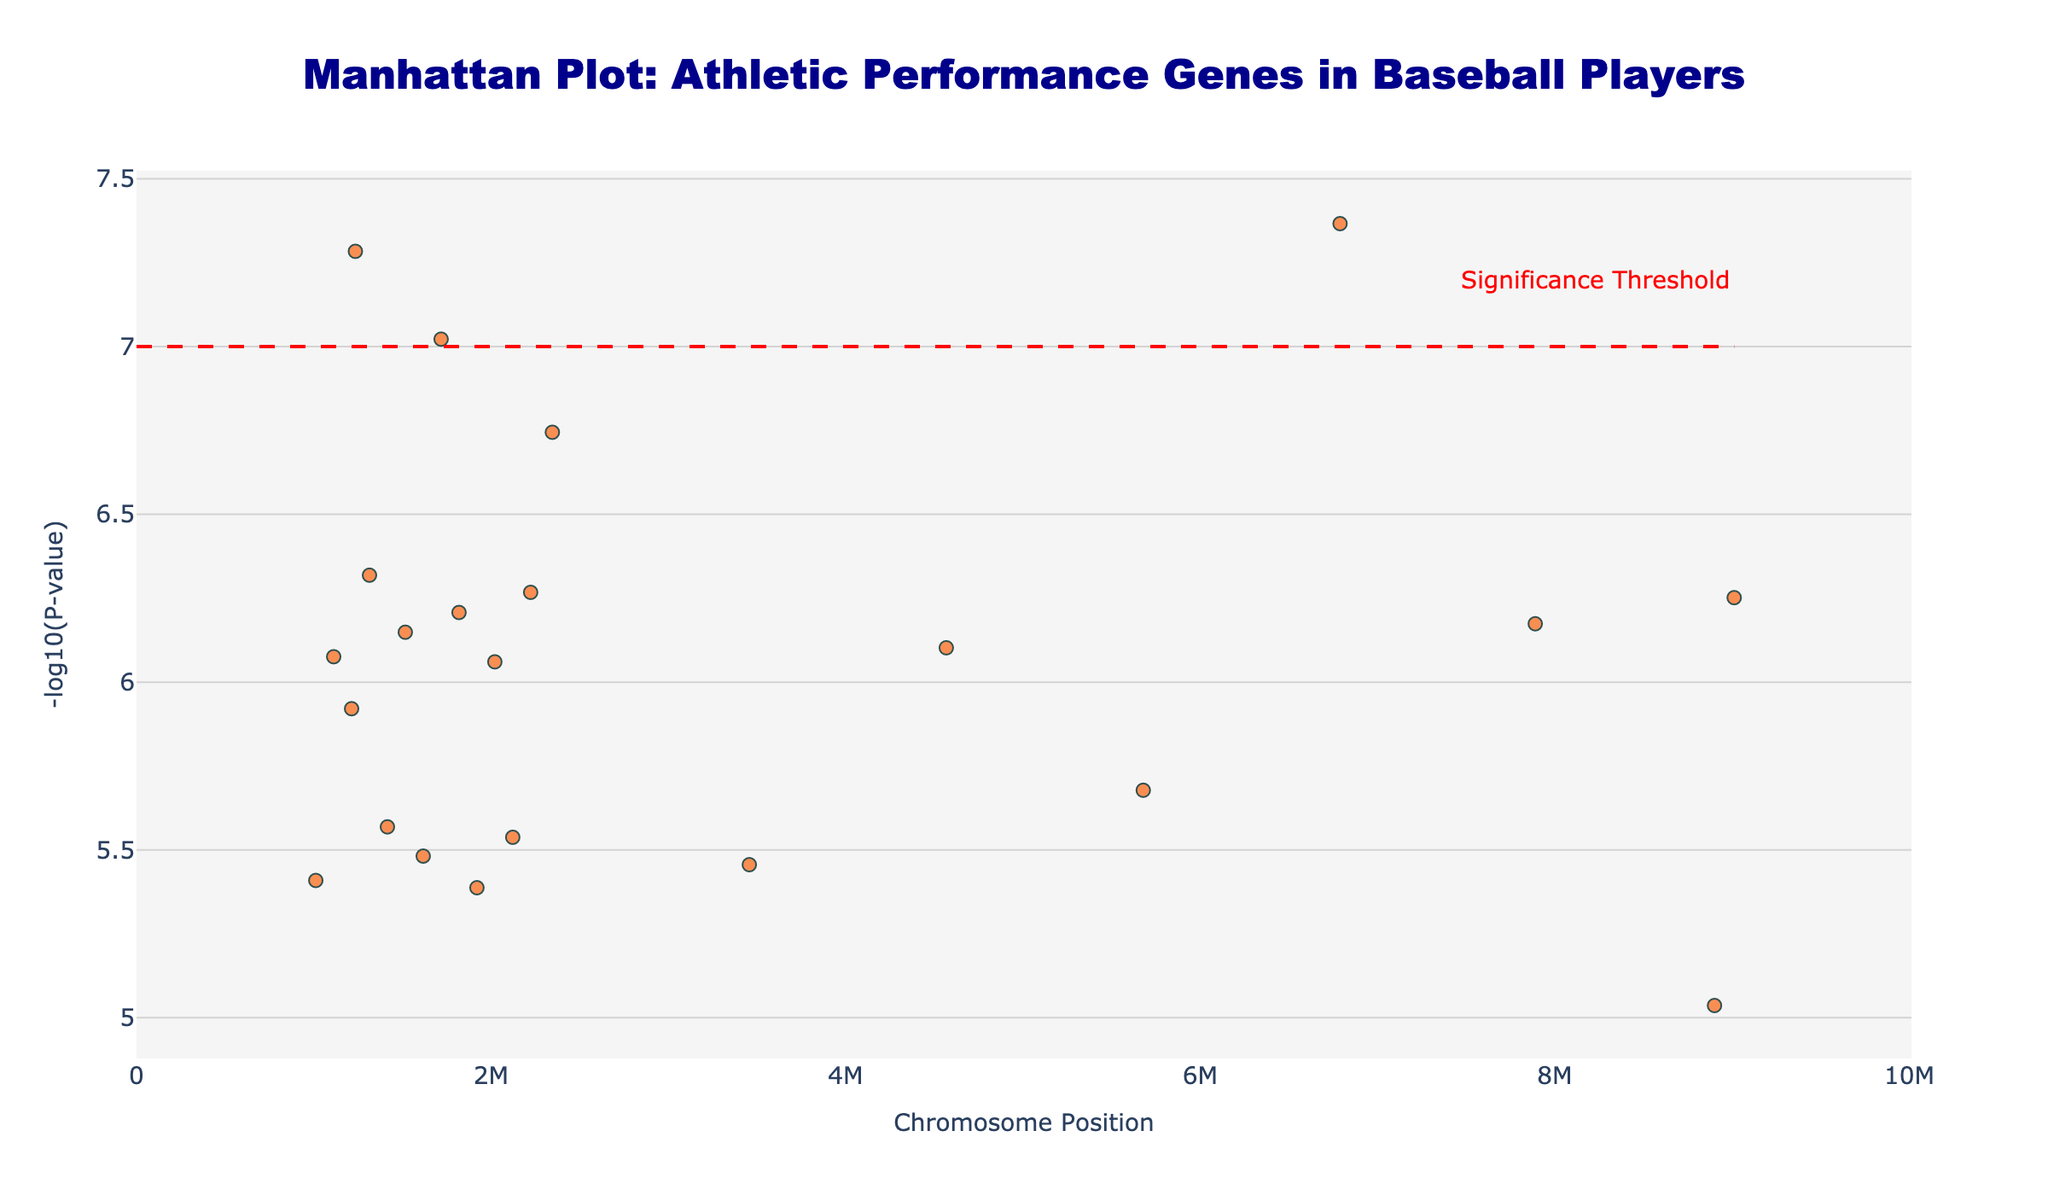what is the title of the figure? The title is displayed at the top center of the plot, written in a large, bold font.
Answer: Manhattan Plot: Athletic Performance Genes in Baseball Players what does the y-axis represent? The y-axis represents the -log10(P-value) of the genes included in the study. This is a measure of statistical significance.
Answer: -log10(P-value) At what P-value is the significance threshold set? The significance threshold is indicated by a horizontal red dashed line on the plot, located at approximately y=7. The corresponding P-value is 10^-7.
Answer: 10^-7 Which chromosome has the gene with the lowest P-value? By comparing the y-values along the y-axis, we notice that the gene with the highest -log10(P-value) (which corresponds to the lowest P-value) is located on chromosome 17.
Answer: Chromosome 17 What gene is located at position 1234567 on Chromosome 1, and what trait does it relate to? Hovering over the Manhattan plot data point at position 1234567 on Chromosome 1 reveals the information about the gene and associated trait.
Answer: ACTN3; Muscle power How many genes have a -log10(P-value) greater than 6? By visually inspecting the plot, one can count the number of markers that are positioned above the y=6 line. There are 12 markers above this line.
Answer: 12 Which gene is associated with hand-eye coordination, and what is its -log10(P-value)? Hovering over the data points on the plot and matching the gene associated with hand-eye coordination shows that NFIA-AS2 is the gene and its -log10(P-value) is the highest.
Answer: NFIA-AS2; -log10(P-value) is ~7.02 What chromosomal positions have genes with -log10(P-value) between 6 and 7? By examining the data points on the plot that fall within the y-range of 6 and 7, we can identify the chromosomal positions associated. Examples include positions 2345678, 4567890, etc.
Answer: Positions 2345678, 4567890, and more Compare the athletic performance traits related to Chromosome 5 and Chromosome 16. What differences do you observe? Chromosome 5 is associated with Altitude adaptation (HIF1A), and Chromosome 16 is related to Angiogenesis (VEGF). These traits differ in physiological functionality - one is for endurance in high-altitude environments, and the other is for new blood vessel formation.
Answer: Altitude adaptation vs. Angiogenesis How many chromosomes have genes with a -log10(P-value) less than the significance threshold? The red dashed line indicates the significance threshold at y=7. By noting the chromosomes without markers above this threshold, we count 20 chromosomes.
Answer: 20 